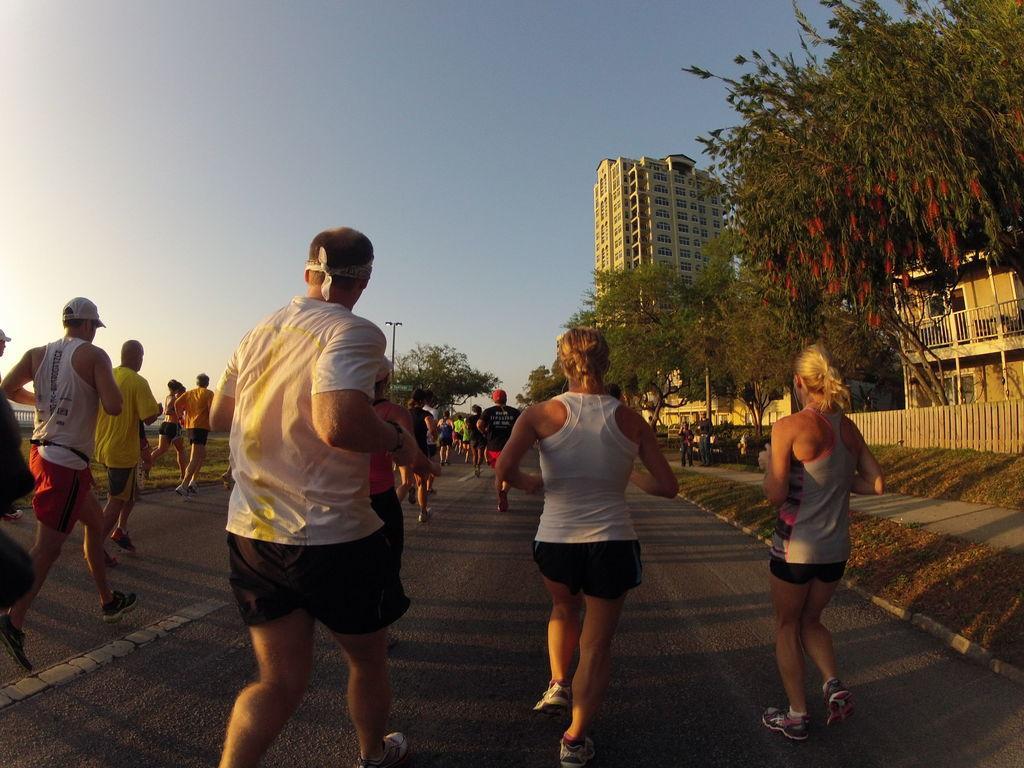In one or two sentences, can you explain what this image depicts? In this image, we can see a group of people are running on the road. Background we can see trees, grass, poles, house, building and sky. 